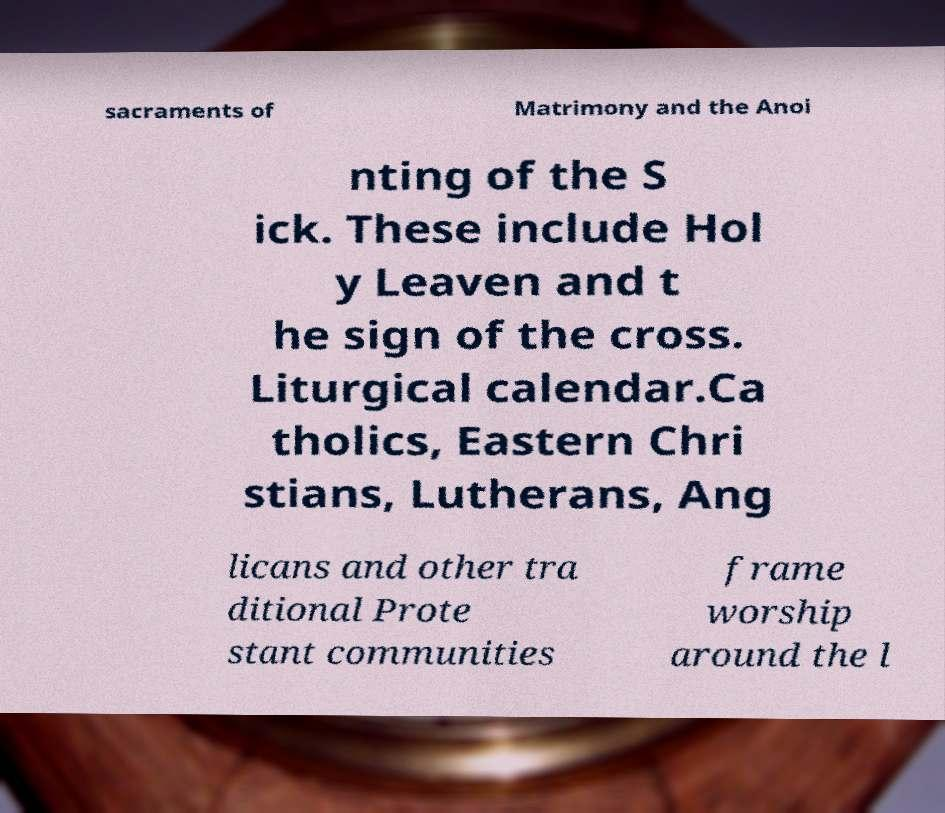For documentation purposes, I need the text within this image transcribed. Could you provide that? sacraments of Matrimony and the Anoi nting of the S ick. These include Hol y Leaven and t he sign of the cross. Liturgical calendar.Ca tholics, Eastern Chri stians, Lutherans, Ang licans and other tra ditional Prote stant communities frame worship around the l 